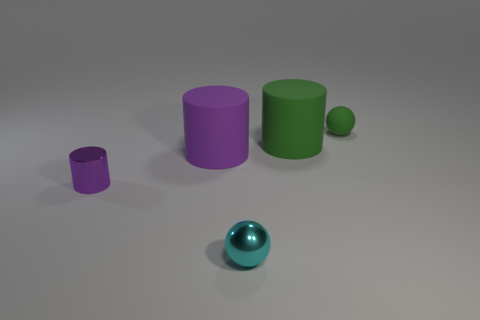Do the purple thing behind the small purple thing and the tiny green object have the same shape?
Ensure brevity in your answer.  No. Are any big matte objects visible?
Provide a short and direct response. Yes. Is there any other thing that is the same shape as the small cyan object?
Make the answer very short. Yes. Are there more big green rubber objects in front of the cyan metallic object than big blue shiny balls?
Make the answer very short. No. There is a metallic sphere; are there any green rubber objects on the left side of it?
Your answer should be compact. No. Does the green ball have the same size as the green cylinder?
Give a very brief answer. No. There is a metal object that is the same shape as the large purple matte object; what is its size?
Offer a very short reply. Small. The sphere that is in front of the large cylinder on the left side of the small metallic sphere is made of what material?
Provide a succinct answer. Metal. Do the tiny green object and the cyan metallic thing have the same shape?
Keep it short and to the point. Yes. What number of things are both on the right side of the small purple metal cylinder and to the left of the tiny cyan shiny sphere?
Your response must be concise. 1. 